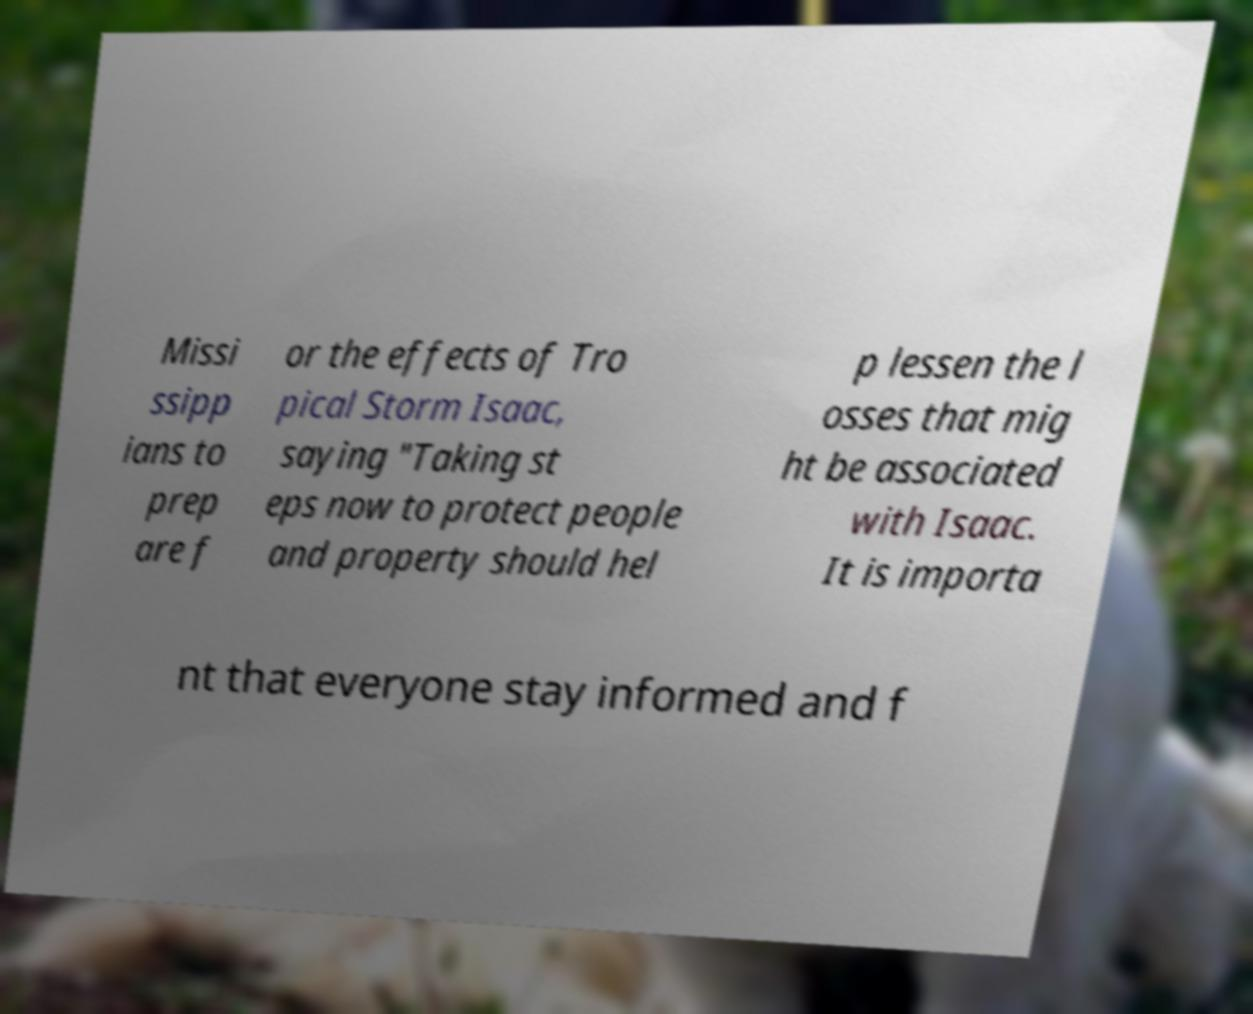What messages or text are displayed in this image? I need them in a readable, typed format. Missi ssipp ians to prep are f or the effects of Tro pical Storm Isaac, saying "Taking st eps now to protect people and property should hel p lessen the l osses that mig ht be associated with Isaac. It is importa nt that everyone stay informed and f 